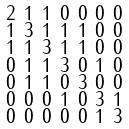<formula> <loc_0><loc_0><loc_500><loc_500>\begin{smallmatrix} 2 & 1 & 1 & 0 & 0 & 0 & 0 \\ 1 & 3 & 1 & 1 & 1 & 0 & 0 \\ 1 & 1 & 3 & 1 & 1 & 0 & 0 \\ 0 & 1 & 1 & 3 & 0 & 1 & 0 \\ 0 & 1 & 1 & 0 & 3 & 0 & 0 \\ 0 & 0 & 0 & 1 & 0 & 3 & 1 \\ 0 & 0 & 0 & 0 & 0 & 1 & 3 \end{smallmatrix}</formula> 